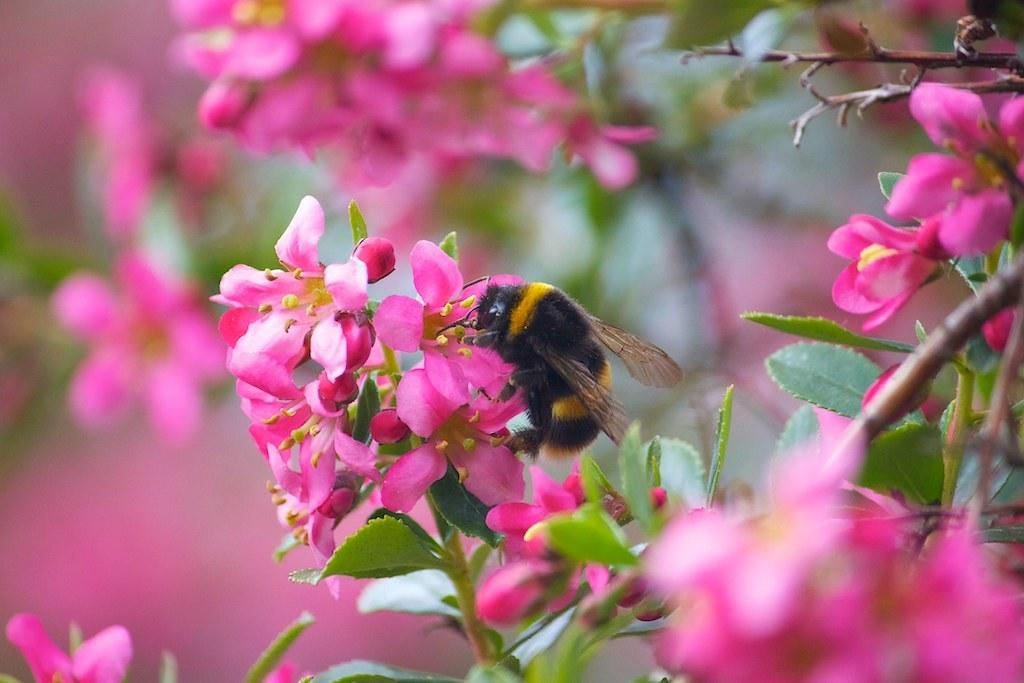What type of creature can be seen in the image? There is an insect in the image. Where is the insect located in the image? The insect is on pink flowers. What type of discovery was made at the front of the image? There is no discovery mentioned in the image, and the term "front" is not relevant to the image's content. 